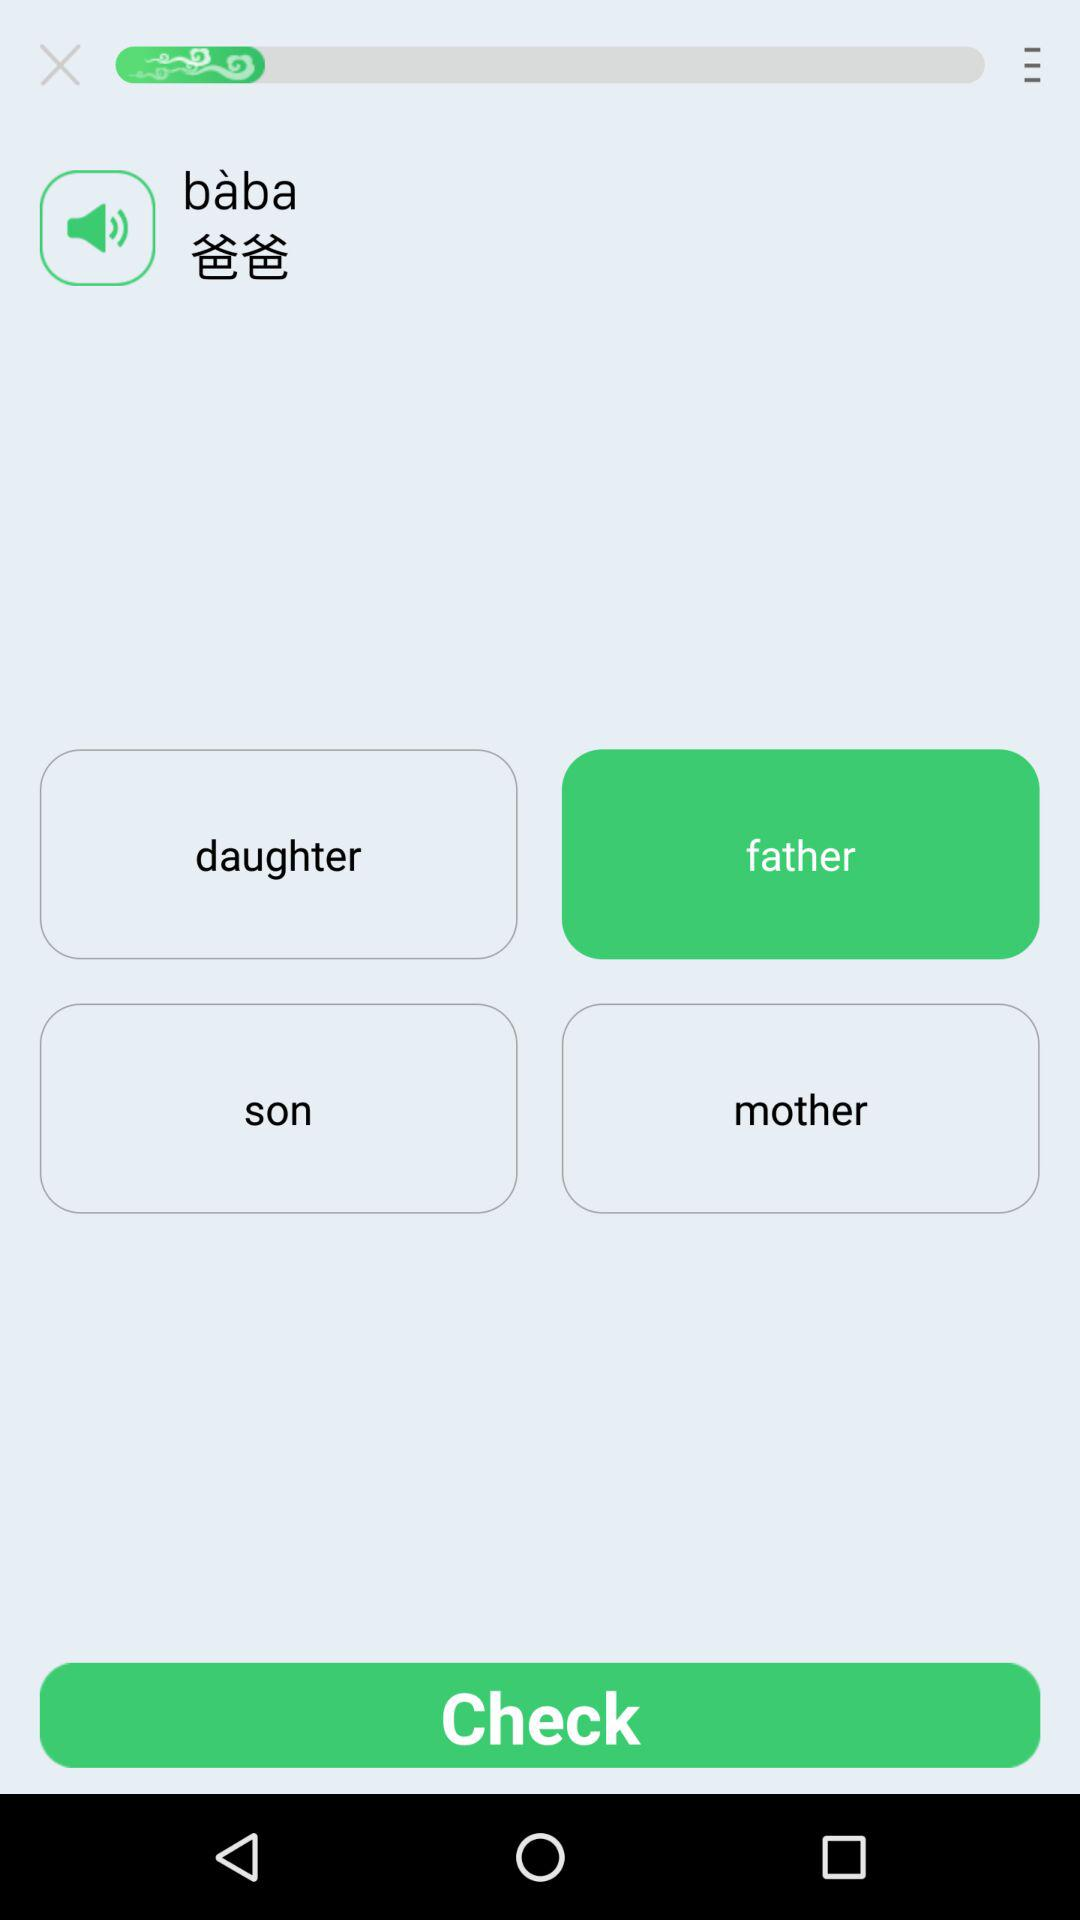What is the selected option? The selected option is Father. 